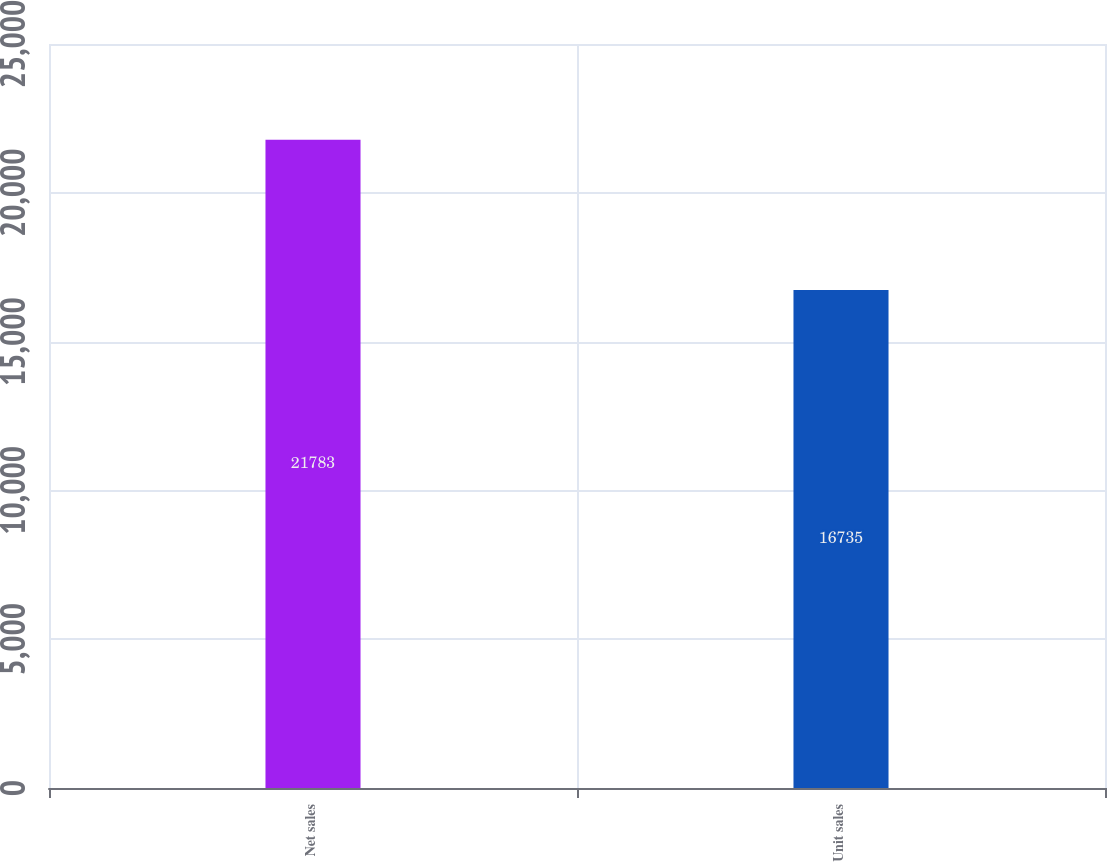Convert chart to OTSL. <chart><loc_0><loc_0><loc_500><loc_500><bar_chart><fcel>Net sales<fcel>Unit sales<nl><fcel>21783<fcel>16735<nl></chart> 